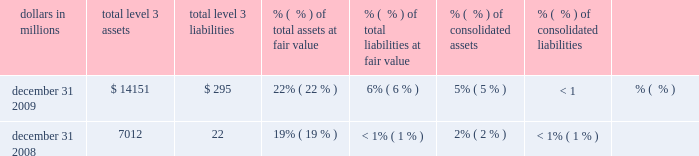Pricing the loans .
When available , valuation assumptions included observable inputs based on whole loan sales .
Adjustments are made to these assumptions to account for situations when uncertainties exist , including market conditions and liquidity .
Credit risk is included as part of our valuation process for these loans by considering expected rates of return for market participants for similar loans in the marketplace .
Based on the significance of unobservable inputs , we classify this portfolio as level 3 .
Equity investments the valuation of direct and indirect private equity investments requires significant management judgment due to the absence of quoted market prices , inherent lack of liquidity and the long-term nature of such investments .
The carrying values of direct and affiliated partnership interests reflect the expected exit price and are based on various techniques including publicly traded price , multiples of adjusted earnings of the entity , independent appraisals , anticipated financing and sale transactions with third parties , or the pricing used to value the entity in a recent financing transaction .
In september 2009 , the fasb issued asu 2009-12 2013 fair value measurements and disclosures ( topic 820 ) 2013 investments in certain entities that calculate net asset value per share ( or its equivalent ) .
Based on the guidance , we value indirect investments in private equity funds based on net asset value as provided in the financial statements that we receive from their managers .
Due to the time lag in our receipt of the financial information and based on a review of investments and valuation techniques applied , adjustments to the manager-provided value are made when available recent portfolio company information or market information indicates a significant change in value from that provided by the manager of the fund .
These investments are classified as level 3 .
Customer resale agreements we account for structured resale agreements , which are economically hedged using free-standing financial derivatives , at fair value .
The fair value for structured resale agreements is determined using a model which includes observable market data such as interest rates as inputs .
Readily observable market inputs to this model can be validated to external sources , including yield curves , implied volatility or other market-related data .
These instruments are classified as level 2 .
Blackrock series c preferred stock effective february 27 , 2009 , we elected to account for the approximately 2.9 million shares of the blackrock series c preferred stock received in a stock exchange with blackrock at fair value .
The series c preferred stock economically hedges the blackrock ltip liability that is accounted for as a derivative .
The fair value of the series c preferred stock is determined using a third-party modeling approach , which includes both observable and unobservable inputs .
This approach considers expectations of a default/liquidation event and the use of liquidity discounts based on our inability to sell the security at a fair , open market price in a timely manner .
Due to the significance of unobservable inputs , this security is classified as level 3 .
Level 3 assets and liabilities financial instruments are considered level 3 when their values are determined using pricing models , discounted cash flow methodologies or similar techniques and at least one significant model assumption or input is unobservable .
Level 3 assets and liabilities dollars in millions level 3 assets level 3 liabilities % (  % ) of total assets at fair value % (  % ) of total liabilities at fair value consolidated assets consolidated liabilities .
During 2009 , securities transferred into level 3 from level 2 exceeded securities transferred out by $ 4.4 billion .
Total securities measured at fair value and classified in level 3 at december 31 , 2009 and december 31 , 2008 included securities available for sale and trading securities consisting primarily of non-agency residential mortgage-backed securities and asset- backed securities where management determined that the volume and level of activity for these assets had significantly decreased .
There have been no recent new 201cprivate label 201d issues in the residential mortgage-backed securities market .
The lack of relevant market activity for these securities resulted in management modifying its valuation methodology for the instruments transferred in 2009 .
Other level 3 assets include certain commercial mortgage loans held for sale , certain equity securities , auction rate securities , corporate debt securities , private equity investments , residential mortgage servicing rights and other assets. .
What was the increase in level 3 assets between december 31 2009 and december 31 2008 , in millions? 
Computations: (14151 - 7012)
Answer: 7139.0. 